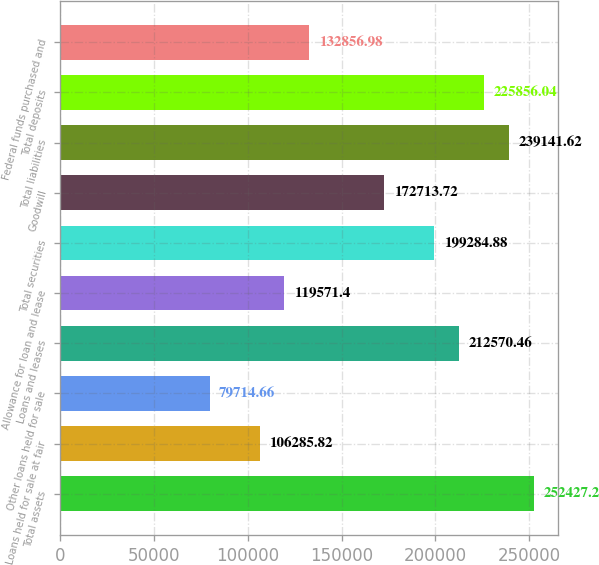Convert chart. <chart><loc_0><loc_0><loc_500><loc_500><bar_chart><fcel>Total assets<fcel>Loans held for sale at fair<fcel>Other loans held for sale<fcel>Loans and leases<fcel>Allowance for loan and lease<fcel>Total securities<fcel>Goodwill<fcel>Total liabilities<fcel>Total deposits<fcel>Federal funds purchased and<nl><fcel>252427<fcel>106286<fcel>79714.7<fcel>212570<fcel>119571<fcel>199285<fcel>172714<fcel>239142<fcel>225856<fcel>132857<nl></chart> 